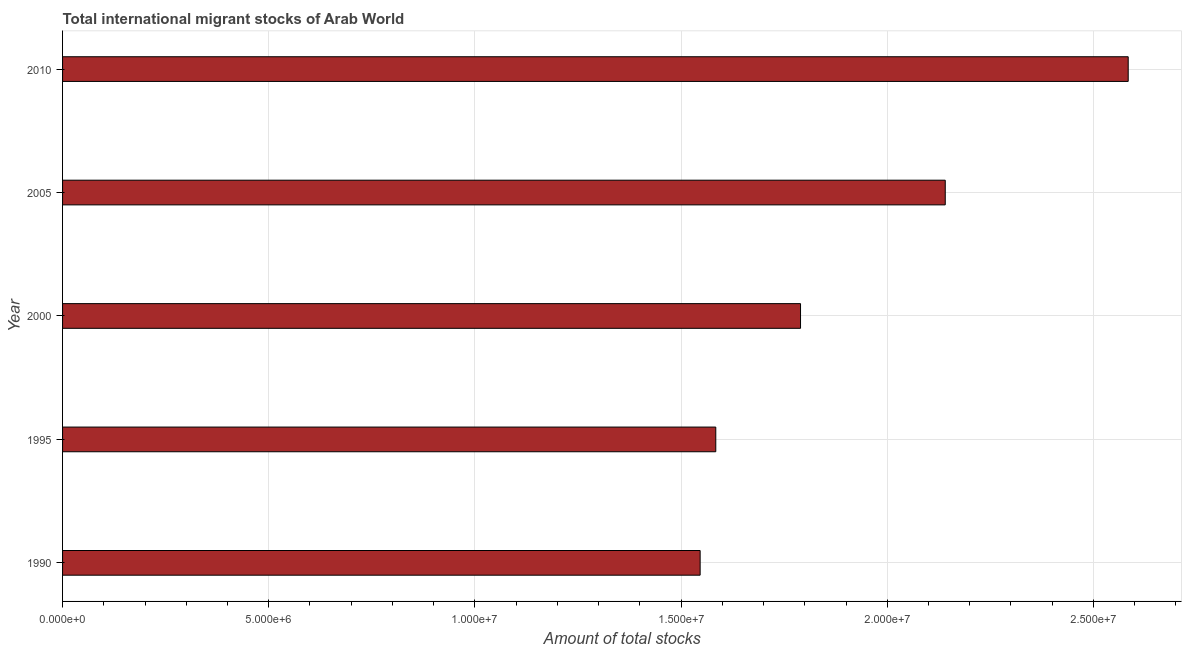What is the title of the graph?
Make the answer very short. Total international migrant stocks of Arab World. What is the label or title of the X-axis?
Provide a short and direct response. Amount of total stocks. What is the total number of international migrant stock in 1990?
Your answer should be compact. 1.55e+07. Across all years, what is the maximum total number of international migrant stock?
Provide a short and direct response. 2.58e+07. Across all years, what is the minimum total number of international migrant stock?
Keep it short and to the point. 1.55e+07. In which year was the total number of international migrant stock maximum?
Ensure brevity in your answer.  2010. In which year was the total number of international migrant stock minimum?
Ensure brevity in your answer.  1990. What is the sum of the total number of international migrant stock?
Provide a short and direct response. 9.65e+07. What is the difference between the total number of international migrant stock in 2000 and 2010?
Offer a very short reply. -7.95e+06. What is the average total number of international migrant stock per year?
Offer a terse response. 1.93e+07. What is the median total number of international migrant stock?
Offer a very short reply. 1.79e+07. In how many years, is the total number of international migrant stock greater than 12000000 ?
Offer a terse response. 5. What is the ratio of the total number of international migrant stock in 1995 to that in 2000?
Your answer should be compact. 0.89. Is the difference between the total number of international migrant stock in 1990 and 1995 greater than the difference between any two years?
Offer a very short reply. No. What is the difference between the highest and the second highest total number of international migrant stock?
Ensure brevity in your answer.  4.44e+06. What is the difference between the highest and the lowest total number of international migrant stock?
Your response must be concise. 1.04e+07. In how many years, is the total number of international migrant stock greater than the average total number of international migrant stock taken over all years?
Provide a succinct answer. 2. How many bars are there?
Your response must be concise. 5. How many years are there in the graph?
Your answer should be compact. 5. What is the Amount of total stocks in 1990?
Your answer should be compact. 1.55e+07. What is the Amount of total stocks of 1995?
Offer a terse response. 1.58e+07. What is the Amount of total stocks of 2000?
Give a very brief answer. 1.79e+07. What is the Amount of total stocks of 2005?
Provide a short and direct response. 2.14e+07. What is the Amount of total stocks of 2010?
Your answer should be very brief. 2.58e+07. What is the difference between the Amount of total stocks in 1990 and 1995?
Your answer should be very brief. -3.79e+05. What is the difference between the Amount of total stocks in 1990 and 2000?
Make the answer very short. -2.43e+06. What is the difference between the Amount of total stocks in 1990 and 2005?
Your answer should be very brief. -5.94e+06. What is the difference between the Amount of total stocks in 1990 and 2010?
Make the answer very short. -1.04e+07. What is the difference between the Amount of total stocks in 1995 and 2000?
Give a very brief answer. -2.06e+06. What is the difference between the Amount of total stocks in 1995 and 2005?
Your answer should be compact. -5.57e+06. What is the difference between the Amount of total stocks in 1995 and 2010?
Keep it short and to the point. -1.00e+07. What is the difference between the Amount of total stocks in 2000 and 2005?
Provide a short and direct response. -3.51e+06. What is the difference between the Amount of total stocks in 2000 and 2010?
Ensure brevity in your answer.  -7.95e+06. What is the difference between the Amount of total stocks in 2005 and 2010?
Provide a succinct answer. -4.44e+06. What is the ratio of the Amount of total stocks in 1990 to that in 2000?
Keep it short and to the point. 0.86. What is the ratio of the Amount of total stocks in 1990 to that in 2005?
Your response must be concise. 0.72. What is the ratio of the Amount of total stocks in 1990 to that in 2010?
Give a very brief answer. 0.6. What is the ratio of the Amount of total stocks in 1995 to that in 2000?
Ensure brevity in your answer.  0.89. What is the ratio of the Amount of total stocks in 1995 to that in 2005?
Ensure brevity in your answer.  0.74. What is the ratio of the Amount of total stocks in 1995 to that in 2010?
Keep it short and to the point. 0.61. What is the ratio of the Amount of total stocks in 2000 to that in 2005?
Provide a succinct answer. 0.84. What is the ratio of the Amount of total stocks in 2000 to that in 2010?
Offer a terse response. 0.69. What is the ratio of the Amount of total stocks in 2005 to that in 2010?
Keep it short and to the point. 0.83. 